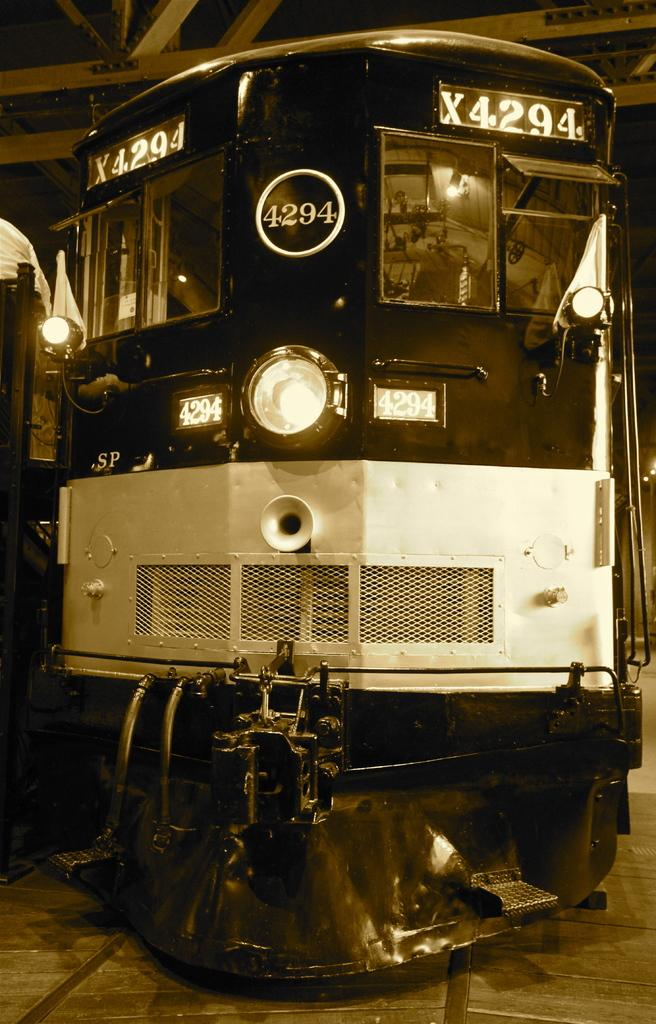What is the color scheme of the image? The image is black and white. What is the main subject of the image? The image depicts a train engine. From which angle is the train engine viewed in the image? The view of the train engine is from the front side. How many rabbits can be seen playing in the aftermath of the train engine in the image? There are no rabbits or any indication of an aftermath in the image; it solely depicts a black and white train engine from the front side. 